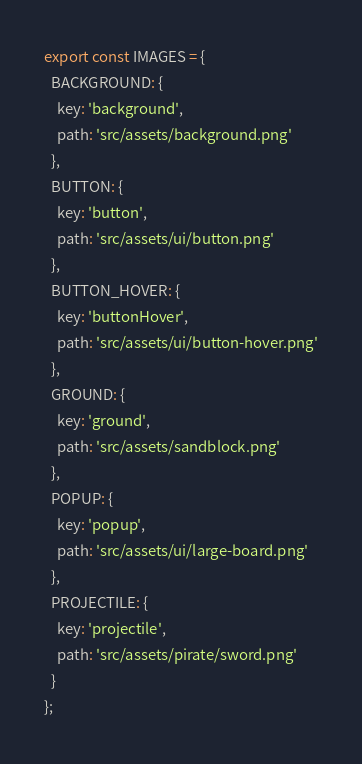<code> <loc_0><loc_0><loc_500><loc_500><_JavaScript_>export const IMAGES = {
  BACKGROUND: {
    key: 'background',
    path: 'src/assets/background.png'
  },
  BUTTON: {
    key: 'button',
    path: 'src/assets/ui/button.png'
  },
  BUTTON_HOVER: {
    key: 'buttonHover',
    path: 'src/assets/ui/button-hover.png'
  },
  GROUND: {
    key: 'ground',
    path: 'src/assets/sandblock.png'
  },
  POPUP: {
    key: 'popup',
    path: 'src/assets/ui/large-board.png'
  },
  PROJECTILE: {
    key: 'projectile',
    path: 'src/assets/pirate/sword.png'
  }
};
</code> 